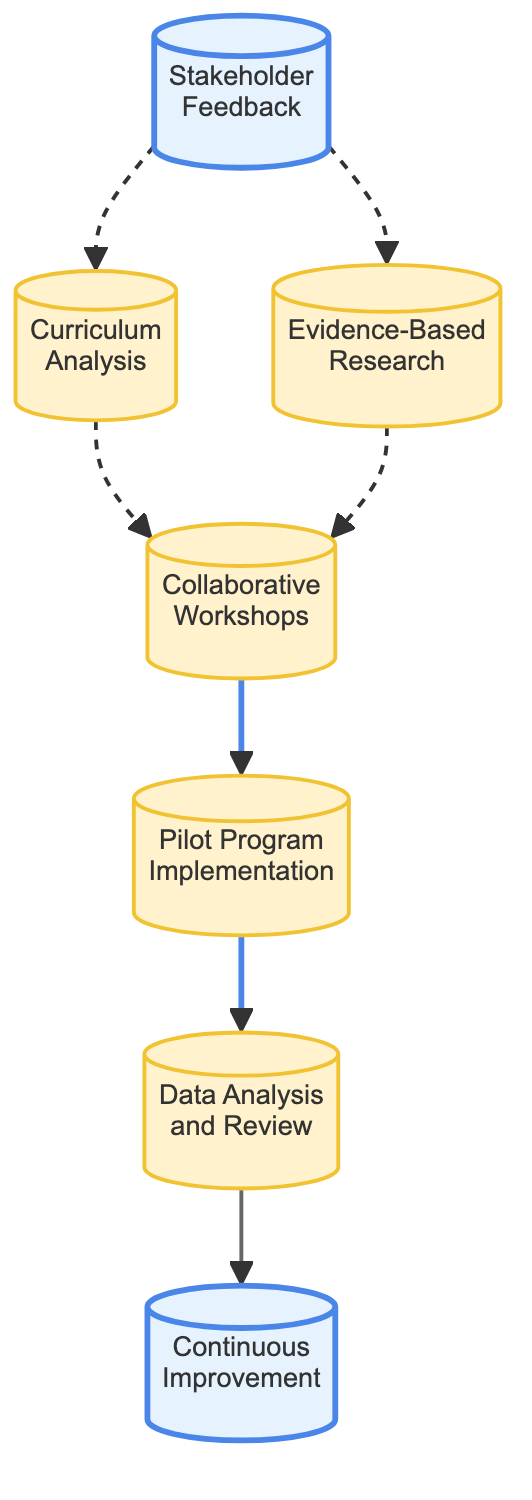What is the first step in the curriculum development process? The diagram shows "Stakeholder Feedback" as the initial node, indicating it is the first step in the process.
Answer: Stakeholder Feedback How many nodes are in the diagram? Counting each distinct element represented in the flow chart, there are seven nodes in total: Stakeholder Feedback, Curriculum Analysis, Evidence-Based Research, Collaborative Workshops, Pilot Program Implementation, Data Analysis and Review, and Continuous Improvement.
Answer: Seven Which nodes lead to "Collaborative Workshops"? The arrows leading into "Collaborative Workshops" come from "Curriculum Analysis" and "Evidence-Based Research," indicating both these nodes contribute to this phase.
Answer: Curriculum Analysis, Evidence-Based Research What is the last step of the curriculum development process? The final node in the flow chart is "Continuous Improvement," which indicates it is the concluding step of the curriculum development process.
Answer: Continuous Improvement Which step follows "Pilot Program Implementation"? The diagram indicates that the step that directly follows "Pilot Program Implementation" is "Data Analysis and Review," suggesting a sequence in the process.
Answer: Data Analysis and Review What role does "Evidence-Based Research" play in the process? The diagram shows that "Evidence-Based Research" is a prerequisite to "Collaborative Workshops," meaning its purpose is to inform the development of the curriculum before moving to workshops.
Answer: Informative How do you advance from "Data Analysis and Review"? Following "Data Analysis and Review," the next phase in the flow chart is "Continuous Improvement," which indicates a progression towards refining the curriculum.
Answer: Continuous Improvement Which elements are classified as intermediate steps? The intermediate steps, highlighted in the diagram, include "Curriculum Analysis," "Evidence-Based Research," "Collaborative Workshops," "Pilot Program Implementation," and "Data Analysis and Review."
Answer: Curriculum Analysis, Evidence-Based Research, Collaborative Workshops, Pilot Program Implementation, Data Analysis and Review What is the nature of links between the first three nodes? The connections from "Stakeholder Feedback" to both "Curriculum Analysis" and "Evidence-Based Research" are represented with dashed lines, indicating a supportive and non-linear relationship among these initial nodes.
Answer: Dashed lines 